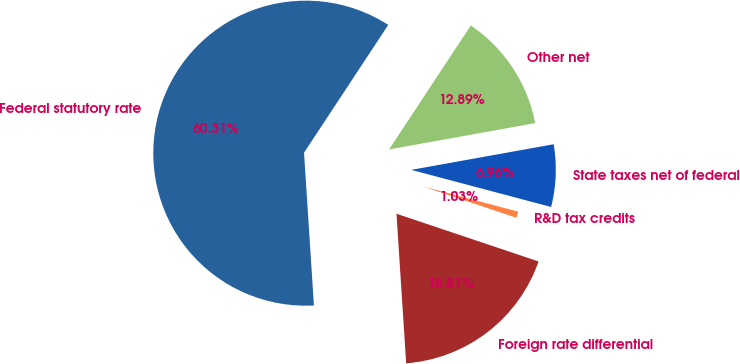Convert chart to OTSL. <chart><loc_0><loc_0><loc_500><loc_500><pie_chart><fcel>Federal statutory rate<fcel>Foreign rate differential<fcel>R&D tax credits<fcel>State taxes net of federal<fcel>Other net<nl><fcel>60.3%<fcel>18.81%<fcel>1.03%<fcel>6.96%<fcel>12.89%<nl></chart> 